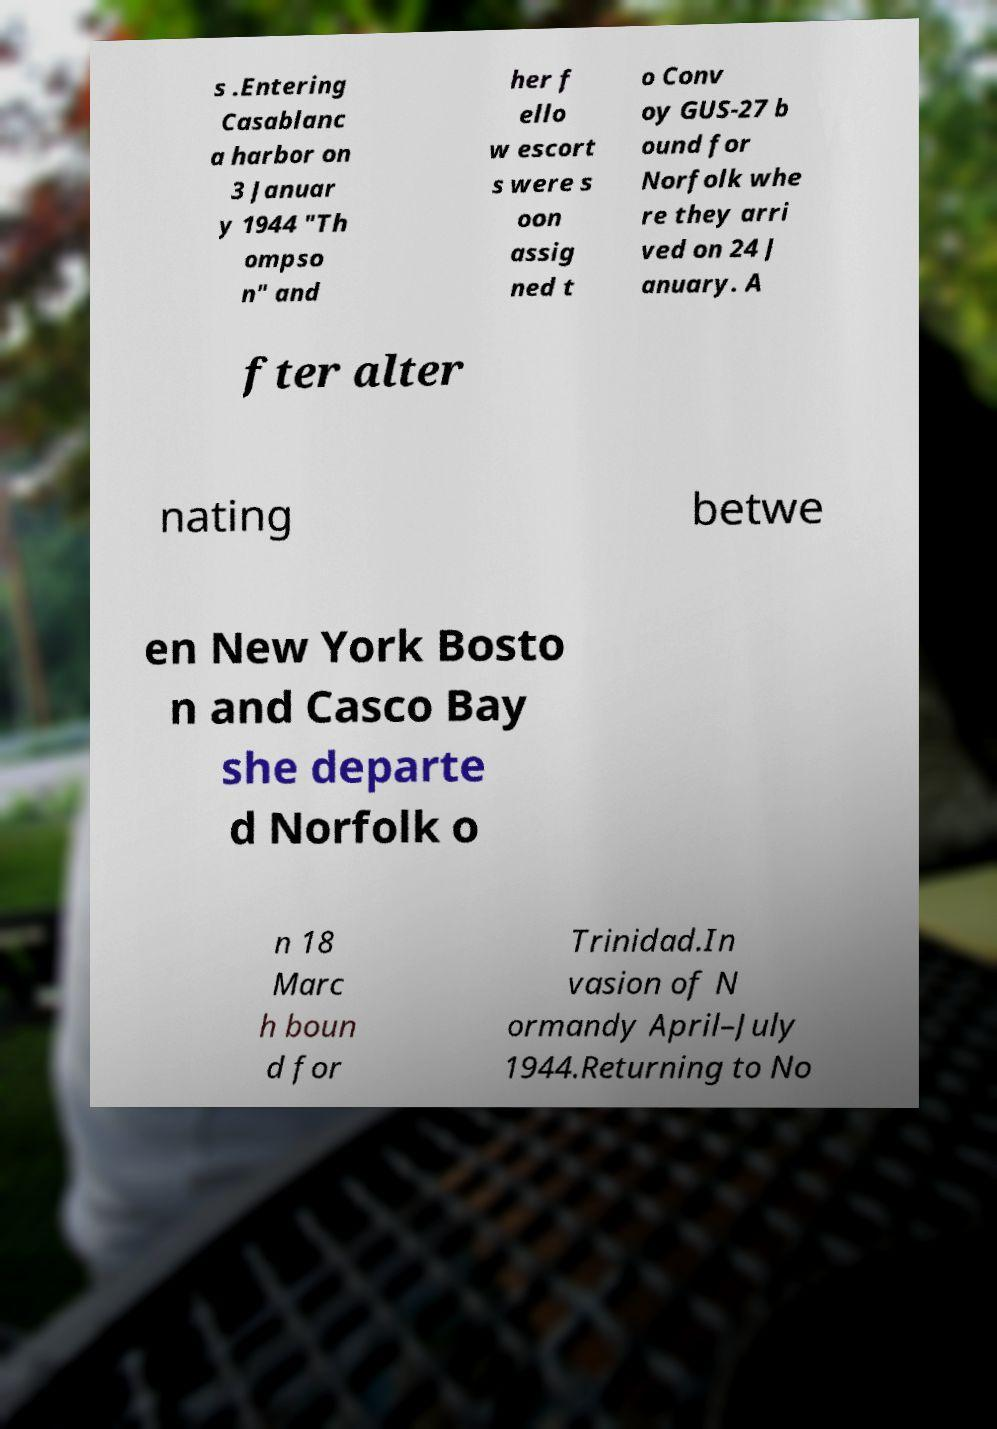I need the written content from this picture converted into text. Can you do that? s .Entering Casablanc a harbor on 3 Januar y 1944 "Th ompso n" and her f ello w escort s were s oon assig ned t o Conv oy GUS-27 b ound for Norfolk whe re they arri ved on 24 J anuary. A fter alter nating betwe en New York Bosto n and Casco Bay she departe d Norfolk o n 18 Marc h boun d for Trinidad.In vasion of N ormandy April–July 1944.Returning to No 